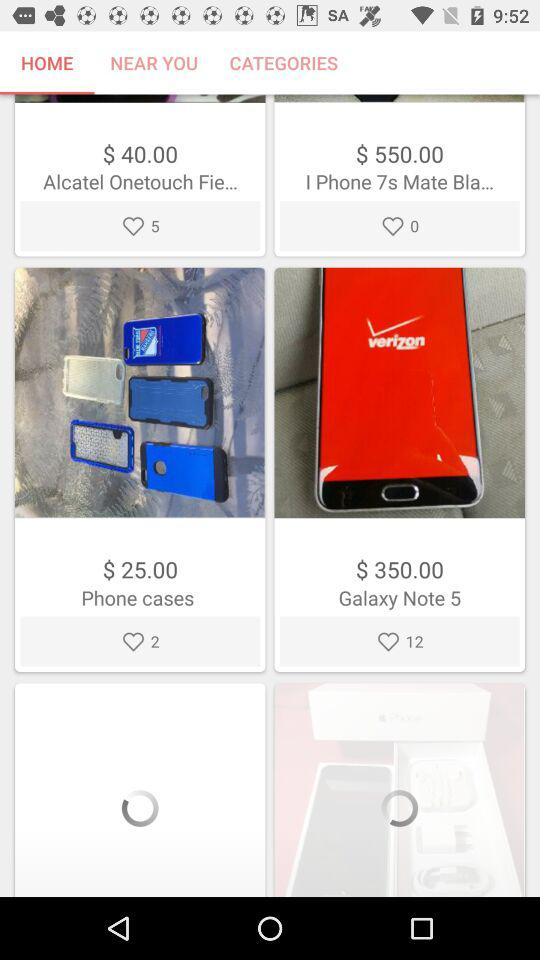What is the number of likes for "Galaxy Note 5"? The number of likes for "Galaxy Note 5" is 12. 